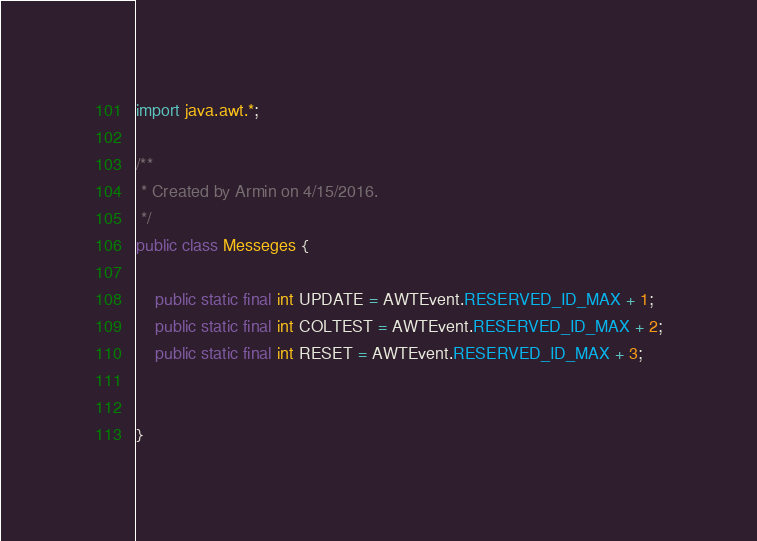Convert code to text. <code><loc_0><loc_0><loc_500><loc_500><_Java_>import java.awt.*;

/**
 * Created by Armin on 4/15/2016.
 */
public class Messeges {

    public static final int UPDATE = AWTEvent.RESERVED_ID_MAX + 1;
    public static final int COLTEST = AWTEvent.RESERVED_ID_MAX + 2;
    public static final int RESET = AWTEvent.RESERVED_ID_MAX + 3;


}
</code> 